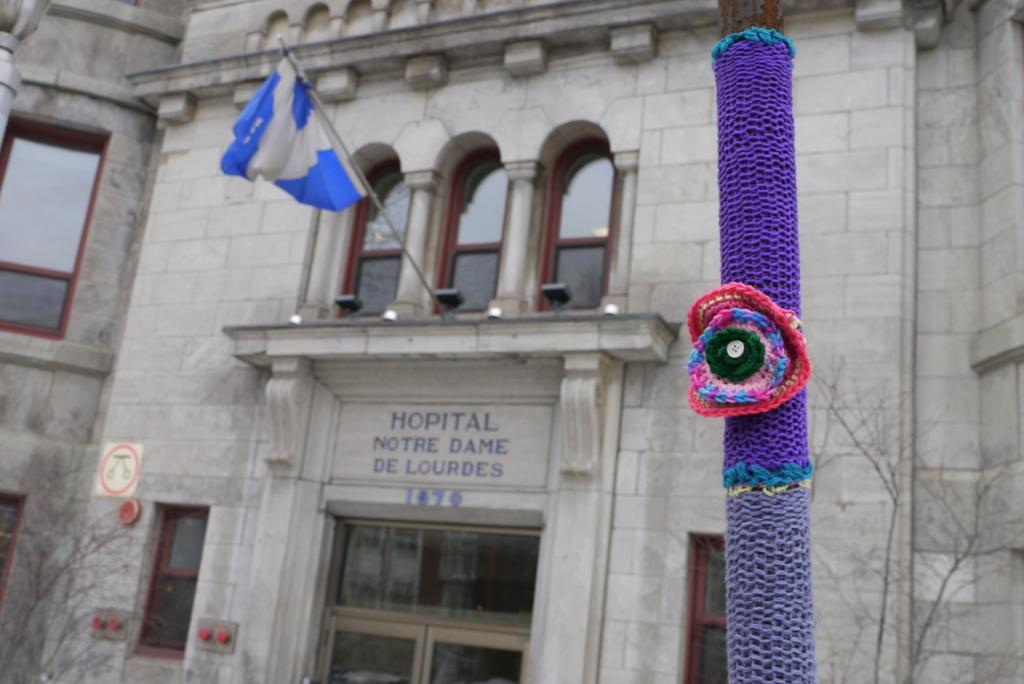What is the main object in the middle of the image? There is a pole in the middle of the image. What can be seen behind the pole? There are plants and a building behind the pole. What features can be observed on the building? The building has windows, a flag, and a sign board. What type of pollution is visible in the image? There is no visible pollution in the image. What order is being followed by the plants in the image? The plants in the image are not following any specific order; they are simply growing behind the pole. 